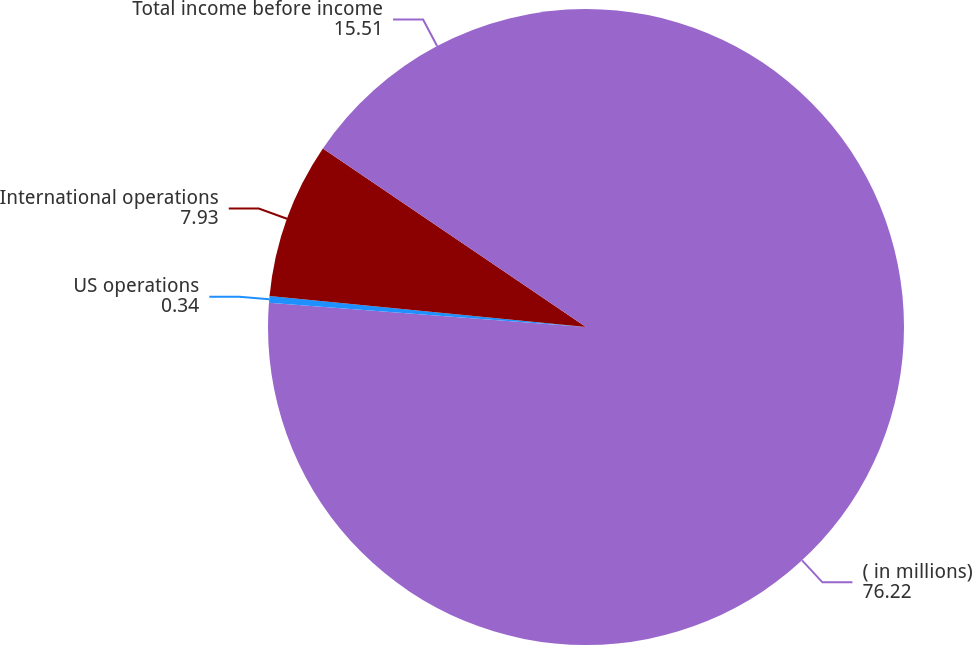Convert chart. <chart><loc_0><loc_0><loc_500><loc_500><pie_chart><fcel>( in millions)<fcel>US operations<fcel>International operations<fcel>Total income before income<nl><fcel>76.22%<fcel>0.34%<fcel>7.93%<fcel>15.51%<nl></chart> 